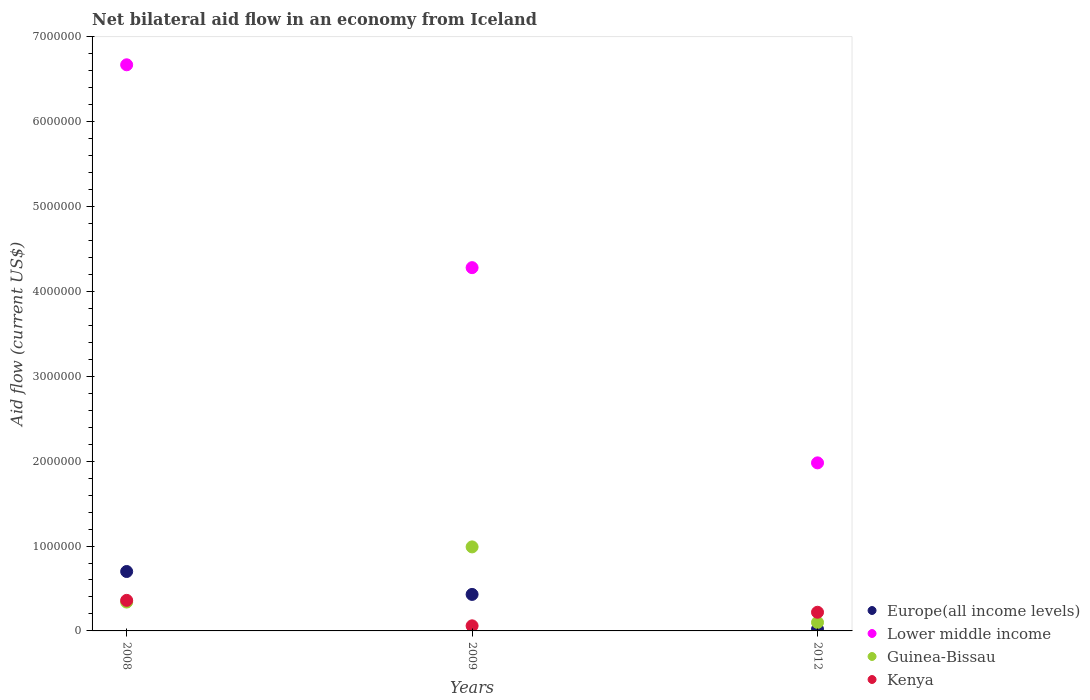Is the number of dotlines equal to the number of legend labels?
Offer a very short reply. Yes. What is the net bilateral aid flow in Guinea-Bissau in 2012?
Make the answer very short. 1.00e+05. Across all years, what is the minimum net bilateral aid flow in Lower middle income?
Your answer should be very brief. 1.98e+06. In which year was the net bilateral aid flow in Europe(all income levels) maximum?
Your answer should be compact. 2008. What is the total net bilateral aid flow in Kenya in the graph?
Give a very brief answer. 6.40e+05. What is the difference between the net bilateral aid flow in Guinea-Bissau in 2009 and that in 2012?
Your answer should be very brief. 8.90e+05. What is the difference between the net bilateral aid flow in Lower middle income in 2012 and the net bilateral aid flow in Guinea-Bissau in 2009?
Give a very brief answer. 9.90e+05. What is the average net bilateral aid flow in Kenya per year?
Offer a very short reply. 2.13e+05. In how many years, is the net bilateral aid flow in Europe(all income levels) greater than 6600000 US$?
Provide a succinct answer. 0. What is the ratio of the net bilateral aid flow in Europe(all income levels) in 2009 to that in 2012?
Provide a succinct answer. 21.5. Is the difference between the net bilateral aid flow in Europe(all income levels) in 2008 and 2009 greater than the difference between the net bilateral aid flow in Guinea-Bissau in 2008 and 2009?
Ensure brevity in your answer.  Yes. What is the difference between the highest and the lowest net bilateral aid flow in Lower middle income?
Your answer should be compact. 4.69e+06. Is the sum of the net bilateral aid flow in Europe(all income levels) in 2008 and 2012 greater than the maximum net bilateral aid flow in Lower middle income across all years?
Provide a succinct answer. No. Does the net bilateral aid flow in Guinea-Bissau monotonically increase over the years?
Ensure brevity in your answer.  No. How many dotlines are there?
Make the answer very short. 4. Are the values on the major ticks of Y-axis written in scientific E-notation?
Provide a short and direct response. No. Does the graph contain any zero values?
Ensure brevity in your answer.  No. Does the graph contain grids?
Keep it short and to the point. No. What is the title of the graph?
Make the answer very short. Net bilateral aid flow in an economy from Iceland. What is the label or title of the X-axis?
Your response must be concise. Years. What is the Aid flow (current US$) in Lower middle income in 2008?
Give a very brief answer. 6.67e+06. What is the Aid flow (current US$) in Guinea-Bissau in 2008?
Your response must be concise. 3.40e+05. What is the Aid flow (current US$) in Kenya in 2008?
Offer a terse response. 3.60e+05. What is the Aid flow (current US$) of Lower middle income in 2009?
Make the answer very short. 4.28e+06. What is the Aid flow (current US$) in Guinea-Bissau in 2009?
Offer a terse response. 9.90e+05. What is the Aid flow (current US$) of Kenya in 2009?
Make the answer very short. 6.00e+04. What is the Aid flow (current US$) of Europe(all income levels) in 2012?
Offer a very short reply. 2.00e+04. What is the Aid flow (current US$) in Lower middle income in 2012?
Make the answer very short. 1.98e+06. What is the Aid flow (current US$) in Guinea-Bissau in 2012?
Your response must be concise. 1.00e+05. What is the Aid flow (current US$) of Kenya in 2012?
Your answer should be compact. 2.20e+05. Across all years, what is the maximum Aid flow (current US$) in Lower middle income?
Ensure brevity in your answer.  6.67e+06. Across all years, what is the maximum Aid flow (current US$) of Guinea-Bissau?
Your answer should be compact. 9.90e+05. Across all years, what is the minimum Aid flow (current US$) of Lower middle income?
Offer a terse response. 1.98e+06. Across all years, what is the minimum Aid flow (current US$) in Kenya?
Provide a succinct answer. 6.00e+04. What is the total Aid flow (current US$) in Europe(all income levels) in the graph?
Offer a terse response. 1.15e+06. What is the total Aid flow (current US$) of Lower middle income in the graph?
Offer a terse response. 1.29e+07. What is the total Aid flow (current US$) in Guinea-Bissau in the graph?
Your answer should be very brief. 1.43e+06. What is the total Aid flow (current US$) in Kenya in the graph?
Make the answer very short. 6.40e+05. What is the difference between the Aid flow (current US$) of Europe(all income levels) in 2008 and that in 2009?
Provide a succinct answer. 2.70e+05. What is the difference between the Aid flow (current US$) in Lower middle income in 2008 and that in 2009?
Give a very brief answer. 2.39e+06. What is the difference between the Aid flow (current US$) of Guinea-Bissau in 2008 and that in 2009?
Give a very brief answer. -6.50e+05. What is the difference between the Aid flow (current US$) in Europe(all income levels) in 2008 and that in 2012?
Keep it short and to the point. 6.80e+05. What is the difference between the Aid flow (current US$) in Lower middle income in 2008 and that in 2012?
Your answer should be very brief. 4.69e+06. What is the difference between the Aid flow (current US$) in Guinea-Bissau in 2008 and that in 2012?
Provide a succinct answer. 2.40e+05. What is the difference between the Aid flow (current US$) of Lower middle income in 2009 and that in 2012?
Your answer should be compact. 2.30e+06. What is the difference between the Aid flow (current US$) in Guinea-Bissau in 2009 and that in 2012?
Keep it short and to the point. 8.90e+05. What is the difference between the Aid flow (current US$) of Europe(all income levels) in 2008 and the Aid flow (current US$) of Lower middle income in 2009?
Offer a terse response. -3.58e+06. What is the difference between the Aid flow (current US$) in Europe(all income levels) in 2008 and the Aid flow (current US$) in Guinea-Bissau in 2009?
Ensure brevity in your answer.  -2.90e+05. What is the difference between the Aid flow (current US$) of Europe(all income levels) in 2008 and the Aid flow (current US$) of Kenya in 2009?
Your response must be concise. 6.40e+05. What is the difference between the Aid flow (current US$) in Lower middle income in 2008 and the Aid flow (current US$) in Guinea-Bissau in 2009?
Offer a terse response. 5.68e+06. What is the difference between the Aid flow (current US$) of Lower middle income in 2008 and the Aid flow (current US$) of Kenya in 2009?
Ensure brevity in your answer.  6.61e+06. What is the difference between the Aid flow (current US$) in Guinea-Bissau in 2008 and the Aid flow (current US$) in Kenya in 2009?
Offer a very short reply. 2.80e+05. What is the difference between the Aid flow (current US$) in Europe(all income levels) in 2008 and the Aid flow (current US$) in Lower middle income in 2012?
Offer a very short reply. -1.28e+06. What is the difference between the Aid flow (current US$) in Europe(all income levels) in 2008 and the Aid flow (current US$) in Kenya in 2012?
Give a very brief answer. 4.80e+05. What is the difference between the Aid flow (current US$) in Lower middle income in 2008 and the Aid flow (current US$) in Guinea-Bissau in 2012?
Give a very brief answer. 6.57e+06. What is the difference between the Aid flow (current US$) in Lower middle income in 2008 and the Aid flow (current US$) in Kenya in 2012?
Offer a very short reply. 6.45e+06. What is the difference between the Aid flow (current US$) in Guinea-Bissau in 2008 and the Aid flow (current US$) in Kenya in 2012?
Your answer should be compact. 1.20e+05. What is the difference between the Aid flow (current US$) in Europe(all income levels) in 2009 and the Aid flow (current US$) in Lower middle income in 2012?
Provide a succinct answer. -1.55e+06. What is the difference between the Aid flow (current US$) in Lower middle income in 2009 and the Aid flow (current US$) in Guinea-Bissau in 2012?
Make the answer very short. 4.18e+06. What is the difference between the Aid flow (current US$) in Lower middle income in 2009 and the Aid flow (current US$) in Kenya in 2012?
Your answer should be very brief. 4.06e+06. What is the difference between the Aid flow (current US$) in Guinea-Bissau in 2009 and the Aid flow (current US$) in Kenya in 2012?
Keep it short and to the point. 7.70e+05. What is the average Aid flow (current US$) in Europe(all income levels) per year?
Your response must be concise. 3.83e+05. What is the average Aid flow (current US$) of Lower middle income per year?
Make the answer very short. 4.31e+06. What is the average Aid flow (current US$) in Guinea-Bissau per year?
Your response must be concise. 4.77e+05. What is the average Aid flow (current US$) of Kenya per year?
Provide a short and direct response. 2.13e+05. In the year 2008, what is the difference between the Aid flow (current US$) in Europe(all income levels) and Aid flow (current US$) in Lower middle income?
Provide a succinct answer. -5.97e+06. In the year 2008, what is the difference between the Aid flow (current US$) of Lower middle income and Aid flow (current US$) of Guinea-Bissau?
Provide a short and direct response. 6.33e+06. In the year 2008, what is the difference between the Aid flow (current US$) of Lower middle income and Aid flow (current US$) of Kenya?
Keep it short and to the point. 6.31e+06. In the year 2008, what is the difference between the Aid flow (current US$) of Guinea-Bissau and Aid flow (current US$) of Kenya?
Your response must be concise. -2.00e+04. In the year 2009, what is the difference between the Aid flow (current US$) of Europe(all income levels) and Aid flow (current US$) of Lower middle income?
Keep it short and to the point. -3.85e+06. In the year 2009, what is the difference between the Aid flow (current US$) in Europe(all income levels) and Aid flow (current US$) in Guinea-Bissau?
Provide a short and direct response. -5.60e+05. In the year 2009, what is the difference between the Aid flow (current US$) in Lower middle income and Aid flow (current US$) in Guinea-Bissau?
Provide a short and direct response. 3.29e+06. In the year 2009, what is the difference between the Aid flow (current US$) in Lower middle income and Aid flow (current US$) in Kenya?
Provide a succinct answer. 4.22e+06. In the year 2009, what is the difference between the Aid flow (current US$) in Guinea-Bissau and Aid flow (current US$) in Kenya?
Offer a very short reply. 9.30e+05. In the year 2012, what is the difference between the Aid flow (current US$) in Europe(all income levels) and Aid flow (current US$) in Lower middle income?
Provide a short and direct response. -1.96e+06. In the year 2012, what is the difference between the Aid flow (current US$) in Europe(all income levels) and Aid flow (current US$) in Kenya?
Provide a short and direct response. -2.00e+05. In the year 2012, what is the difference between the Aid flow (current US$) in Lower middle income and Aid flow (current US$) in Guinea-Bissau?
Ensure brevity in your answer.  1.88e+06. In the year 2012, what is the difference between the Aid flow (current US$) of Lower middle income and Aid flow (current US$) of Kenya?
Keep it short and to the point. 1.76e+06. In the year 2012, what is the difference between the Aid flow (current US$) in Guinea-Bissau and Aid flow (current US$) in Kenya?
Give a very brief answer. -1.20e+05. What is the ratio of the Aid flow (current US$) of Europe(all income levels) in 2008 to that in 2009?
Offer a very short reply. 1.63. What is the ratio of the Aid flow (current US$) in Lower middle income in 2008 to that in 2009?
Keep it short and to the point. 1.56. What is the ratio of the Aid flow (current US$) in Guinea-Bissau in 2008 to that in 2009?
Keep it short and to the point. 0.34. What is the ratio of the Aid flow (current US$) in Kenya in 2008 to that in 2009?
Your response must be concise. 6. What is the ratio of the Aid flow (current US$) in Lower middle income in 2008 to that in 2012?
Your response must be concise. 3.37. What is the ratio of the Aid flow (current US$) in Kenya in 2008 to that in 2012?
Provide a short and direct response. 1.64. What is the ratio of the Aid flow (current US$) in Europe(all income levels) in 2009 to that in 2012?
Give a very brief answer. 21.5. What is the ratio of the Aid flow (current US$) of Lower middle income in 2009 to that in 2012?
Offer a very short reply. 2.16. What is the ratio of the Aid flow (current US$) in Guinea-Bissau in 2009 to that in 2012?
Keep it short and to the point. 9.9. What is the ratio of the Aid flow (current US$) of Kenya in 2009 to that in 2012?
Your response must be concise. 0.27. What is the difference between the highest and the second highest Aid flow (current US$) in Lower middle income?
Offer a terse response. 2.39e+06. What is the difference between the highest and the second highest Aid flow (current US$) of Guinea-Bissau?
Keep it short and to the point. 6.50e+05. What is the difference between the highest and the second highest Aid flow (current US$) in Kenya?
Ensure brevity in your answer.  1.40e+05. What is the difference between the highest and the lowest Aid flow (current US$) in Europe(all income levels)?
Make the answer very short. 6.80e+05. What is the difference between the highest and the lowest Aid flow (current US$) in Lower middle income?
Make the answer very short. 4.69e+06. What is the difference between the highest and the lowest Aid flow (current US$) in Guinea-Bissau?
Provide a succinct answer. 8.90e+05. 